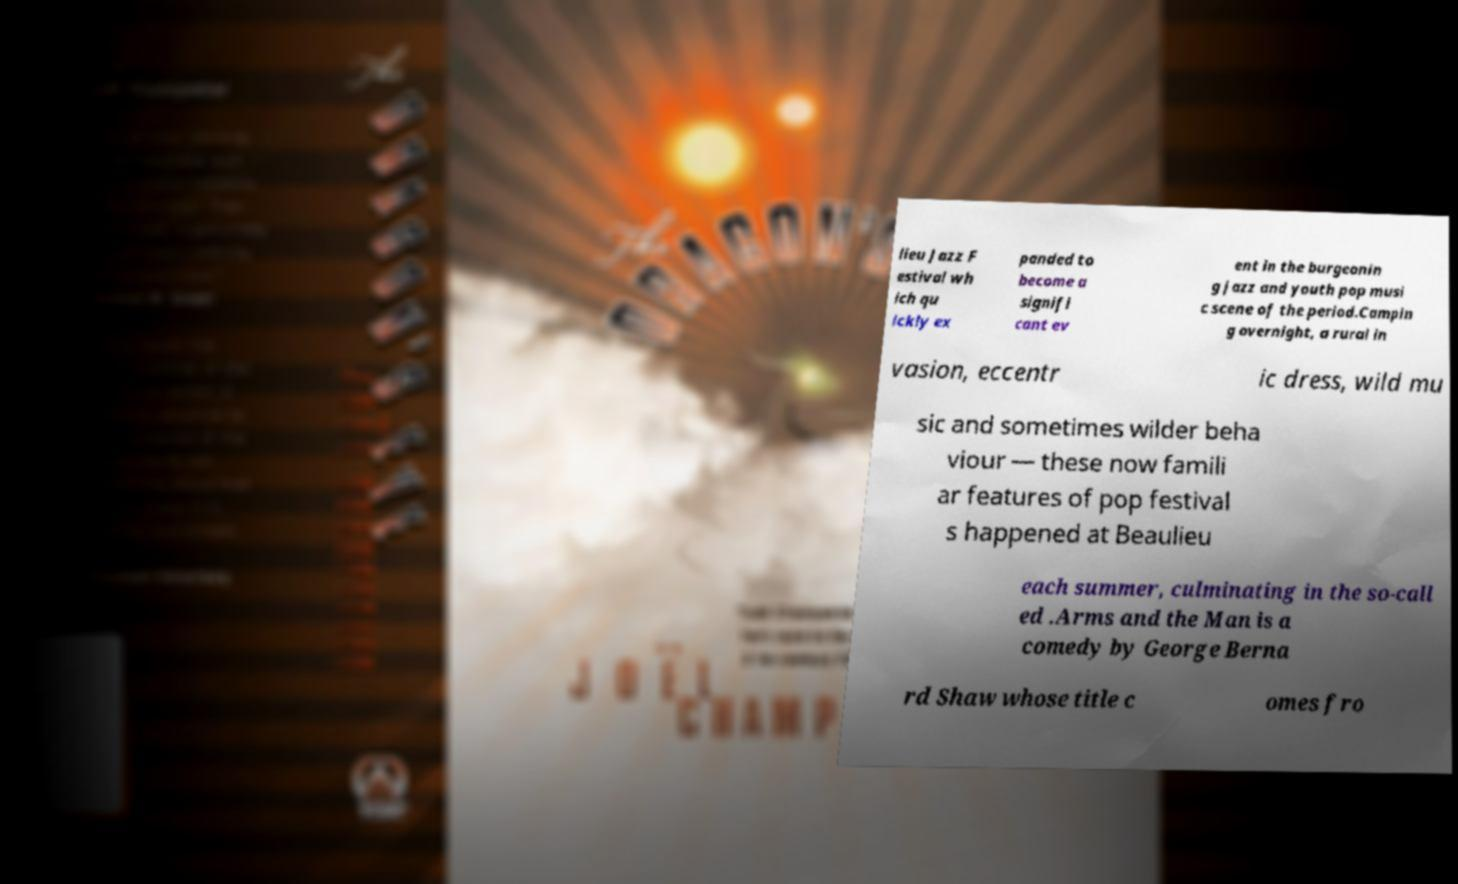For documentation purposes, I need the text within this image transcribed. Could you provide that? lieu Jazz F estival wh ich qu ickly ex panded to become a signifi cant ev ent in the burgeonin g jazz and youth pop musi c scene of the period.Campin g overnight, a rural in vasion, eccentr ic dress, wild mu sic and sometimes wilder beha viour — these now famili ar features of pop festival s happened at Beaulieu each summer, culminating in the so-call ed .Arms and the Man is a comedy by George Berna rd Shaw whose title c omes fro 